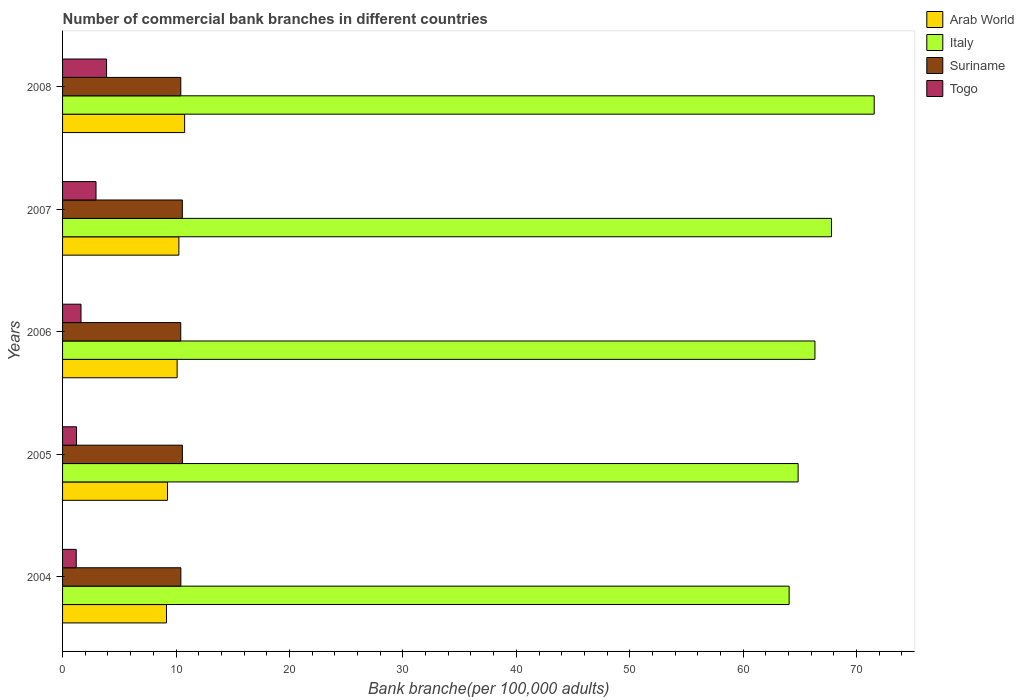How many different coloured bars are there?
Your answer should be very brief. 4. What is the number of commercial bank branches in Italy in 2005?
Give a very brief answer. 64.84. Across all years, what is the maximum number of commercial bank branches in Arab World?
Your answer should be compact. 10.76. Across all years, what is the minimum number of commercial bank branches in Suriname?
Provide a succinct answer. 10.42. In which year was the number of commercial bank branches in Arab World maximum?
Provide a short and direct response. 2008. What is the total number of commercial bank branches in Italy in the graph?
Your answer should be compact. 334.56. What is the difference between the number of commercial bank branches in Togo in 2004 and that in 2008?
Provide a short and direct response. -2.68. What is the difference between the number of commercial bank branches in Suriname in 2004 and the number of commercial bank branches in Arab World in 2006?
Your answer should be very brief. 0.33. What is the average number of commercial bank branches in Italy per year?
Keep it short and to the point. 66.91. In the year 2007, what is the difference between the number of commercial bank branches in Suriname and number of commercial bank branches in Arab World?
Your answer should be very brief. 0.31. In how many years, is the number of commercial bank branches in Togo greater than 36 ?
Your answer should be very brief. 0. What is the ratio of the number of commercial bank branches in Suriname in 2005 to that in 2008?
Give a very brief answer. 1.01. What is the difference between the highest and the second highest number of commercial bank branches in Suriname?
Give a very brief answer. 0. What is the difference between the highest and the lowest number of commercial bank branches in Togo?
Your response must be concise. 2.68. Is the sum of the number of commercial bank branches in Suriname in 2005 and 2007 greater than the maximum number of commercial bank branches in Arab World across all years?
Your answer should be compact. Yes. Is it the case that in every year, the sum of the number of commercial bank branches in Suriname and number of commercial bank branches in Arab World is greater than the number of commercial bank branches in Italy?
Offer a terse response. No. How many bars are there?
Offer a terse response. 20. Are all the bars in the graph horizontal?
Your response must be concise. Yes. How many years are there in the graph?
Provide a succinct answer. 5. Does the graph contain any zero values?
Provide a short and direct response. No. Does the graph contain grids?
Provide a short and direct response. No. What is the title of the graph?
Give a very brief answer. Number of commercial bank branches in different countries. What is the label or title of the X-axis?
Provide a short and direct response. Bank branche(per 100,0 adults). What is the label or title of the Y-axis?
Give a very brief answer. Years. What is the Bank branche(per 100,000 adults) in Arab World in 2004?
Your answer should be very brief. 9.16. What is the Bank branche(per 100,000 adults) of Italy in 2004?
Provide a succinct answer. 64.05. What is the Bank branche(per 100,000 adults) of Suriname in 2004?
Offer a very short reply. 10.43. What is the Bank branche(per 100,000 adults) of Togo in 2004?
Give a very brief answer. 1.2. What is the Bank branche(per 100,000 adults) of Arab World in 2005?
Provide a succinct answer. 9.25. What is the Bank branche(per 100,000 adults) in Italy in 2005?
Provide a succinct answer. 64.84. What is the Bank branche(per 100,000 adults) in Suriname in 2005?
Provide a succinct answer. 10.56. What is the Bank branche(per 100,000 adults) of Togo in 2005?
Your answer should be very brief. 1.23. What is the Bank branche(per 100,000 adults) of Arab World in 2006?
Make the answer very short. 10.1. What is the Bank branche(per 100,000 adults) in Italy in 2006?
Offer a very short reply. 66.33. What is the Bank branche(per 100,000 adults) of Suriname in 2006?
Offer a terse response. 10.42. What is the Bank branche(per 100,000 adults) of Togo in 2006?
Offer a very short reply. 1.63. What is the Bank branche(per 100,000 adults) in Arab World in 2007?
Provide a succinct answer. 10.25. What is the Bank branche(per 100,000 adults) in Italy in 2007?
Give a very brief answer. 67.78. What is the Bank branche(per 100,000 adults) of Suriname in 2007?
Provide a succinct answer. 10.56. What is the Bank branche(per 100,000 adults) in Togo in 2007?
Give a very brief answer. 2.95. What is the Bank branche(per 100,000 adults) in Arab World in 2008?
Provide a succinct answer. 10.76. What is the Bank branche(per 100,000 adults) in Italy in 2008?
Offer a terse response. 71.55. What is the Bank branche(per 100,000 adults) of Suriname in 2008?
Provide a succinct answer. 10.42. What is the Bank branche(per 100,000 adults) in Togo in 2008?
Your response must be concise. 3.88. Across all years, what is the maximum Bank branche(per 100,000 adults) in Arab World?
Make the answer very short. 10.76. Across all years, what is the maximum Bank branche(per 100,000 adults) of Italy?
Ensure brevity in your answer.  71.55. Across all years, what is the maximum Bank branche(per 100,000 adults) in Suriname?
Provide a succinct answer. 10.56. Across all years, what is the maximum Bank branche(per 100,000 adults) in Togo?
Provide a succinct answer. 3.88. Across all years, what is the minimum Bank branche(per 100,000 adults) of Arab World?
Your answer should be very brief. 9.16. Across all years, what is the minimum Bank branche(per 100,000 adults) in Italy?
Your response must be concise. 64.05. Across all years, what is the minimum Bank branche(per 100,000 adults) of Suriname?
Your response must be concise. 10.42. Across all years, what is the minimum Bank branche(per 100,000 adults) of Togo?
Your response must be concise. 1.2. What is the total Bank branche(per 100,000 adults) in Arab World in the graph?
Your response must be concise. 49.52. What is the total Bank branche(per 100,000 adults) of Italy in the graph?
Ensure brevity in your answer.  334.56. What is the total Bank branche(per 100,000 adults) in Suriname in the graph?
Ensure brevity in your answer.  52.39. What is the total Bank branche(per 100,000 adults) of Togo in the graph?
Your response must be concise. 10.89. What is the difference between the Bank branche(per 100,000 adults) in Arab World in 2004 and that in 2005?
Give a very brief answer. -0.09. What is the difference between the Bank branche(per 100,000 adults) of Italy in 2004 and that in 2005?
Your answer should be very brief. -0.79. What is the difference between the Bank branche(per 100,000 adults) in Suriname in 2004 and that in 2005?
Give a very brief answer. -0.14. What is the difference between the Bank branche(per 100,000 adults) in Togo in 2004 and that in 2005?
Keep it short and to the point. -0.03. What is the difference between the Bank branche(per 100,000 adults) in Arab World in 2004 and that in 2006?
Ensure brevity in your answer.  -0.94. What is the difference between the Bank branche(per 100,000 adults) in Italy in 2004 and that in 2006?
Provide a short and direct response. -2.28. What is the difference between the Bank branche(per 100,000 adults) in Suriname in 2004 and that in 2006?
Ensure brevity in your answer.  0.01. What is the difference between the Bank branche(per 100,000 adults) in Togo in 2004 and that in 2006?
Make the answer very short. -0.42. What is the difference between the Bank branche(per 100,000 adults) in Arab World in 2004 and that in 2007?
Your response must be concise. -1.09. What is the difference between the Bank branche(per 100,000 adults) in Italy in 2004 and that in 2007?
Ensure brevity in your answer.  -3.73. What is the difference between the Bank branche(per 100,000 adults) of Suriname in 2004 and that in 2007?
Ensure brevity in your answer.  -0.13. What is the difference between the Bank branche(per 100,000 adults) of Togo in 2004 and that in 2007?
Your answer should be very brief. -1.75. What is the difference between the Bank branche(per 100,000 adults) in Arab World in 2004 and that in 2008?
Make the answer very short. -1.6. What is the difference between the Bank branche(per 100,000 adults) in Italy in 2004 and that in 2008?
Offer a terse response. -7.5. What is the difference between the Bank branche(per 100,000 adults) of Suriname in 2004 and that in 2008?
Offer a very short reply. 0.01. What is the difference between the Bank branche(per 100,000 adults) of Togo in 2004 and that in 2008?
Keep it short and to the point. -2.68. What is the difference between the Bank branche(per 100,000 adults) in Arab World in 2005 and that in 2006?
Provide a short and direct response. -0.85. What is the difference between the Bank branche(per 100,000 adults) of Italy in 2005 and that in 2006?
Provide a succinct answer. -1.48. What is the difference between the Bank branche(per 100,000 adults) of Suriname in 2005 and that in 2006?
Provide a succinct answer. 0.14. What is the difference between the Bank branche(per 100,000 adults) of Togo in 2005 and that in 2006?
Offer a terse response. -0.39. What is the difference between the Bank branche(per 100,000 adults) of Arab World in 2005 and that in 2007?
Your answer should be very brief. -1. What is the difference between the Bank branche(per 100,000 adults) of Italy in 2005 and that in 2007?
Offer a terse response. -2.94. What is the difference between the Bank branche(per 100,000 adults) of Suriname in 2005 and that in 2007?
Keep it short and to the point. 0. What is the difference between the Bank branche(per 100,000 adults) of Togo in 2005 and that in 2007?
Ensure brevity in your answer.  -1.72. What is the difference between the Bank branche(per 100,000 adults) of Arab World in 2005 and that in 2008?
Provide a short and direct response. -1.51. What is the difference between the Bank branche(per 100,000 adults) of Italy in 2005 and that in 2008?
Provide a succinct answer. -6.71. What is the difference between the Bank branche(per 100,000 adults) in Suriname in 2005 and that in 2008?
Ensure brevity in your answer.  0.14. What is the difference between the Bank branche(per 100,000 adults) of Togo in 2005 and that in 2008?
Your response must be concise. -2.65. What is the difference between the Bank branche(per 100,000 adults) in Arab World in 2006 and that in 2007?
Your answer should be compact. -0.15. What is the difference between the Bank branche(per 100,000 adults) of Italy in 2006 and that in 2007?
Provide a succinct answer. -1.46. What is the difference between the Bank branche(per 100,000 adults) of Suriname in 2006 and that in 2007?
Your response must be concise. -0.14. What is the difference between the Bank branche(per 100,000 adults) in Togo in 2006 and that in 2007?
Your response must be concise. -1.32. What is the difference between the Bank branche(per 100,000 adults) of Arab World in 2006 and that in 2008?
Your answer should be very brief. -0.66. What is the difference between the Bank branche(per 100,000 adults) of Italy in 2006 and that in 2008?
Keep it short and to the point. -5.22. What is the difference between the Bank branche(per 100,000 adults) of Suriname in 2006 and that in 2008?
Make the answer very short. -0. What is the difference between the Bank branche(per 100,000 adults) in Togo in 2006 and that in 2008?
Make the answer very short. -2.25. What is the difference between the Bank branche(per 100,000 adults) in Arab World in 2007 and that in 2008?
Provide a succinct answer. -0.51. What is the difference between the Bank branche(per 100,000 adults) in Italy in 2007 and that in 2008?
Your answer should be very brief. -3.77. What is the difference between the Bank branche(per 100,000 adults) in Suriname in 2007 and that in 2008?
Offer a very short reply. 0.14. What is the difference between the Bank branche(per 100,000 adults) of Togo in 2007 and that in 2008?
Ensure brevity in your answer.  -0.93. What is the difference between the Bank branche(per 100,000 adults) of Arab World in 2004 and the Bank branche(per 100,000 adults) of Italy in 2005?
Offer a very short reply. -55.68. What is the difference between the Bank branche(per 100,000 adults) of Arab World in 2004 and the Bank branche(per 100,000 adults) of Suriname in 2005?
Ensure brevity in your answer.  -1.4. What is the difference between the Bank branche(per 100,000 adults) of Arab World in 2004 and the Bank branche(per 100,000 adults) of Togo in 2005?
Your answer should be very brief. 7.93. What is the difference between the Bank branche(per 100,000 adults) of Italy in 2004 and the Bank branche(per 100,000 adults) of Suriname in 2005?
Provide a short and direct response. 53.49. What is the difference between the Bank branche(per 100,000 adults) of Italy in 2004 and the Bank branche(per 100,000 adults) of Togo in 2005?
Make the answer very short. 62.82. What is the difference between the Bank branche(per 100,000 adults) of Suriname in 2004 and the Bank branche(per 100,000 adults) of Togo in 2005?
Your response must be concise. 9.2. What is the difference between the Bank branche(per 100,000 adults) in Arab World in 2004 and the Bank branche(per 100,000 adults) in Italy in 2006?
Ensure brevity in your answer.  -57.17. What is the difference between the Bank branche(per 100,000 adults) of Arab World in 2004 and the Bank branche(per 100,000 adults) of Suriname in 2006?
Offer a very short reply. -1.26. What is the difference between the Bank branche(per 100,000 adults) in Arab World in 2004 and the Bank branche(per 100,000 adults) in Togo in 2006?
Keep it short and to the point. 7.54. What is the difference between the Bank branche(per 100,000 adults) of Italy in 2004 and the Bank branche(per 100,000 adults) of Suriname in 2006?
Offer a terse response. 53.63. What is the difference between the Bank branche(per 100,000 adults) in Italy in 2004 and the Bank branche(per 100,000 adults) in Togo in 2006?
Keep it short and to the point. 62.43. What is the difference between the Bank branche(per 100,000 adults) in Suriname in 2004 and the Bank branche(per 100,000 adults) in Togo in 2006?
Your answer should be very brief. 8.8. What is the difference between the Bank branche(per 100,000 adults) of Arab World in 2004 and the Bank branche(per 100,000 adults) of Italy in 2007?
Provide a short and direct response. -58.62. What is the difference between the Bank branche(per 100,000 adults) in Arab World in 2004 and the Bank branche(per 100,000 adults) in Suriname in 2007?
Your answer should be compact. -1.4. What is the difference between the Bank branche(per 100,000 adults) of Arab World in 2004 and the Bank branche(per 100,000 adults) of Togo in 2007?
Ensure brevity in your answer.  6.21. What is the difference between the Bank branche(per 100,000 adults) of Italy in 2004 and the Bank branche(per 100,000 adults) of Suriname in 2007?
Offer a very short reply. 53.49. What is the difference between the Bank branche(per 100,000 adults) of Italy in 2004 and the Bank branche(per 100,000 adults) of Togo in 2007?
Ensure brevity in your answer.  61.1. What is the difference between the Bank branche(per 100,000 adults) of Suriname in 2004 and the Bank branche(per 100,000 adults) of Togo in 2007?
Provide a short and direct response. 7.48. What is the difference between the Bank branche(per 100,000 adults) of Arab World in 2004 and the Bank branche(per 100,000 adults) of Italy in 2008?
Offer a very short reply. -62.39. What is the difference between the Bank branche(per 100,000 adults) of Arab World in 2004 and the Bank branche(per 100,000 adults) of Suriname in 2008?
Keep it short and to the point. -1.26. What is the difference between the Bank branche(per 100,000 adults) of Arab World in 2004 and the Bank branche(per 100,000 adults) of Togo in 2008?
Provide a short and direct response. 5.28. What is the difference between the Bank branche(per 100,000 adults) in Italy in 2004 and the Bank branche(per 100,000 adults) in Suriname in 2008?
Keep it short and to the point. 53.63. What is the difference between the Bank branche(per 100,000 adults) in Italy in 2004 and the Bank branche(per 100,000 adults) in Togo in 2008?
Provide a short and direct response. 60.17. What is the difference between the Bank branche(per 100,000 adults) of Suriname in 2004 and the Bank branche(per 100,000 adults) of Togo in 2008?
Ensure brevity in your answer.  6.55. What is the difference between the Bank branche(per 100,000 adults) of Arab World in 2005 and the Bank branche(per 100,000 adults) of Italy in 2006?
Your response must be concise. -57.08. What is the difference between the Bank branche(per 100,000 adults) of Arab World in 2005 and the Bank branche(per 100,000 adults) of Suriname in 2006?
Your answer should be very brief. -1.17. What is the difference between the Bank branche(per 100,000 adults) in Arab World in 2005 and the Bank branche(per 100,000 adults) in Togo in 2006?
Offer a terse response. 7.62. What is the difference between the Bank branche(per 100,000 adults) in Italy in 2005 and the Bank branche(per 100,000 adults) in Suriname in 2006?
Make the answer very short. 54.43. What is the difference between the Bank branche(per 100,000 adults) in Italy in 2005 and the Bank branche(per 100,000 adults) in Togo in 2006?
Provide a succinct answer. 63.22. What is the difference between the Bank branche(per 100,000 adults) in Suriname in 2005 and the Bank branche(per 100,000 adults) in Togo in 2006?
Your response must be concise. 8.94. What is the difference between the Bank branche(per 100,000 adults) in Arab World in 2005 and the Bank branche(per 100,000 adults) in Italy in 2007?
Offer a very short reply. -58.53. What is the difference between the Bank branche(per 100,000 adults) in Arab World in 2005 and the Bank branche(per 100,000 adults) in Suriname in 2007?
Provide a short and direct response. -1.31. What is the difference between the Bank branche(per 100,000 adults) in Arab World in 2005 and the Bank branche(per 100,000 adults) in Togo in 2007?
Give a very brief answer. 6.3. What is the difference between the Bank branche(per 100,000 adults) in Italy in 2005 and the Bank branche(per 100,000 adults) in Suriname in 2007?
Provide a succinct answer. 54.29. What is the difference between the Bank branche(per 100,000 adults) in Italy in 2005 and the Bank branche(per 100,000 adults) in Togo in 2007?
Your response must be concise. 61.89. What is the difference between the Bank branche(per 100,000 adults) of Suriname in 2005 and the Bank branche(per 100,000 adults) of Togo in 2007?
Provide a short and direct response. 7.61. What is the difference between the Bank branche(per 100,000 adults) in Arab World in 2005 and the Bank branche(per 100,000 adults) in Italy in 2008?
Give a very brief answer. -62.3. What is the difference between the Bank branche(per 100,000 adults) of Arab World in 2005 and the Bank branche(per 100,000 adults) of Suriname in 2008?
Your answer should be compact. -1.17. What is the difference between the Bank branche(per 100,000 adults) of Arab World in 2005 and the Bank branche(per 100,000 adults) of Togo in 2008?
Your response must be concise. 5.37. What is the difference between the Bank branche(per 100,000 adults) of Italy in 2005 and the Bank branche(per 100,000 adults) of Suriname in 2008?
Offer a very short reply. 54.42. What is the difference between the Bank branche(per 100,000 adults) of Italy in 2005 and the Bank branche(per 100,000 adults) of Togo in 2008?
Your answer should be very brief. 60.96. What is the difference between the Bank branche(per 100,000 adults) in Suriname in 2005 and the Bank branche(per 100,000 adults) in Togo in 2008?
Offer a very short reply. 6.68. What is the difference between the Bank branche(per 100,000 adults) of Arab World in 2006 and the Bank branche(per 100,000 adults) of Italy in 2007?
Your answer should be very brief. -57.68. What is the difference between the Bank branche(per 100,000 adults) in Arab World in 2006 and the Bank branche(per 100,000 adults) in Suriname in 2007?
Make the answer very short. -0.46. What is the difference between the Bank branche(per 100,000 adults) in Arab World in 2006 and the Bank branche(per 100,000 adults) in Togo in 2007?
Your answer should be compact. 7.15. What is the difference between the Bank branche(per 100,000 adults) in Italy in 2006 and the Bank branche(per 100,000 adults) in Suriname in 2007?
Give a very brief answer. 55.77. What is the difference between the Bank branche(per 100,000 adults) in Italy in 2006 and the Bank branche(per 100,000 adults) in Togo in 2007?
Your answer should be very brief. 63.38. What is the difference between the Bank branche(per 100,000 adults) in Suriname in 2006 and the Bank branche(per 100,000 adults) in Togo in 2007?
Offer a very short reply. 7.47. What is the difference between the Bank branche(per 100,000 adults) in Arab World in 2006 and the Bank branche(per 100,000 adults) in Italy in 2008?
Ensure brevity in your answer.  -61.45. What is the difference between the Bank branche(per 100,000 adults) of Arab World in 2006 and the Bank branche(per 100,000 adults) of Suriname in 2008?
Offer a terse response. -0.32. What is the difference between the Bank branche(per 100,000 adults) in Arab World in 2006 and the Bank branche(per 100,000 adults) in Togo in 2008?
Make the answer very short. 6.22. What is the difference between the Bank branche(per 100,000 adults) of Italy in 2006 and the Bank branche(per 100,000 adults) of Suriname in 2008?
Make the answer very short. 55.9. What is the difference between the Bank branche(per 100,000 adults) in Italy in 2006 and the Bank branche(per 100,000 adults) in Togo in 2008?
Keep it short and to the point. 62.45. What is the difference between the Bank branche(per 100,000 adults) in Suriname in 2006 and the Bank branche(per 100,000 adults) in Togo in 2008?
Your response must be concise. 6.54. What is the difference between the Bank branche(per 100,000 adults) of Arab World in 2007 and the Bank branche(per 100,000 adults) of Italy in 2008?
Your answer should be very brief. -61.3. What is the difference between the Bank branche(per 100,000 adults) of Arab World in 2007 and the Bank branche(per 100,000 adults) of Suriname in 2008?
Ensure brevity in your answer.  -0.17. What is the difference between the Bank branche(per 100,000 adults) in Arab World in 2007 and the Bank branche(per 100,000 adults) in Togo in 2008?
Make the answer very short. 6.37. What is the difference between the Bank branche(per 100,000 adults) in Italy in 2007 and the Bank branche(per 100,000 adults) in Suriname in 2008?
Give a very brief answer. 57.36. What is the difference between the Bank branche(per 100,000 adults) of Italy in 2007 and the Bank branche(per 100,000 adults) of Togo in 2008?
Offer a terse response. 63.9. What is the difference between the Bank branche(per 100,000 adults) in Suriname in 2007 and the Bank branche(per 100,000 adults) in Togo in 2008?
Ensure brevity in your answer.  6.68. What is the average Bank branche(per 100,000 adults) of Arab World per year?
Ensure brevity in your answer.  9.9. What is the average Bank branche(per 100,000 adults) in Italy per year?
Provide a succinct answer. 66.91. What is the average Bank branche(per 100,000 adults) in Suriname per year?
Keep it short and to the point. 10.48. What is the average Bank branche(per 100,000 adults) of Togo per year?
Offer a terse response. 2.18. In the year 2004, what is the difference between the Bank branche(per 100,000 adults) of Arab World and Bank branche(per 100,000 adults) of Italy?
Keep it short and to the point. -54.89. In the year 2004, what is the difference between the Bank branche(per 100,000 adults) of Arab World and Bank branche(per 100,000 adults) of Suriname?
Ensure brevity in your answer.  -1.27. In the year 2004, what is the difference between the Bank branche(per 100,000 adults) of Arab World and Bank branche(per 100,000 adults) of Togo?
Offer a terse response. 7.96. In the year 2004, what is the difference between the Bank branche(per 100,000 adults) of Italy and Bank branche(per 100,000 adults) of Suriname?
Your answer should be compact. 53.62. In the year 2004, what is the difference between the Bank branche(per 100,000 adults) in Italy and Bank branche(per 100,000 adults) in Togo?
Your answer should be very brief. 62.85. In the year 2004, what is the difference between the Bank branche(per 100,000 adults) of Suriname and Bank branche(per 100,000 adults) of Togo?
Your response must be concise. 9.22. In the year 2005, what is the difference between the Bank branche(per 100,000 adults) in Arab World and Bank branche(per 100,000 adults) in Italy?
Your response must be concise. -55.59. In the year 2005, what is the difference between the Bank branche(per 100,000 adults) of Arab World and Bank branche(per 100,000 adults) of Suriname?
Your response must be concise. -1.31. In the year 2005, what is the difference between the Bank branche(per 100,000 adults) of Arab World and Bank branche(per 100,000 adults) of Togo?
Provide a short and direct response. 8.02. In the year 2005, what is the difference between the Bank branche(per 100,000 adults) in Italy and Bank branche(per 100,000 adults) in Suriname?
Your answer should be compact. 54.28. In the year 2005, what is the difference between the Bank branche(per 100,000 adults) in Italy and Bank branche(per 100,000 adults) in Togo?
Provide a succinct answer. 63.61. In the year 2005, what is the difference between the Bank branche(per 100,000 adults) in Suriname and Bank branche(per 100,000 adults) in Togo?
Make the answer very short. 9.33. In the year 2006, what is the difference between the Bank branche(per 100,000 adults) of Arab World and Bank branche(per 100,000 adults) of Italy?
Offer a terse response. -56.23. In the year 2006, what is the difference between the Bank branche(per 100,000 adults) in Arab World and Bank branche(per 100,000 adults) in Suriname?
Offer a terse response. -0.32. In the year 2006, what is the difference between the Bank branche(per 100,000 adults) in Arab World and Bank branche(per 100,000 adults) in Togo?
Give a very brief answer. 8.47. In the year 2006, what is the difference between the Bank branche(per 100,000 adults) in Italy and Bank branche(per 100,000 adults) in Suriname?
Your answer should be compact. 55.91. In the year 2006, what is the difference between the Bank branche(per 100,000 adults) in Italy and Bank branche(per 100,000 adults) in Togo?
Ensure brevity in your answer.  64.7. In the year 2006, what is the difference between the Bank branche(per 100,000 adults) in Suriname and Bank branche(per 100,000 adults) in Togo?
Offer a very short reply. 8.79. In the year 2007, what is the difference between the Bank branche(per 100,000 adults) in Arab World and Bank branche(per 100,000 adults) in Italy?
Your answer should be compact. -57.53. In the year 2007, what is the difference between the Bank branche(per 100,000 adults) of Arab World and Bank branche(per 100,000 adults) of Suriname?
Keep it short and to the point. -0.31. In the year 2007, what is the difference between the Bank branche(per 100,000 adults) in Arab World and Bank branche(per 100,000 adults) in Togo?
Give a very brief answer. 7.3. In the year 2007, what is the difference between the Bank branche(per 100,000 adults) of Italy and Bank branche(per 100,000 adults) of Suriname?
Keep it short and to the point. 57.22. In the year 2007, what is the difference between the Bank branche(per 100,000 adults) of Italy and Bank branche(per 100,000 adults) of Togo?
Your answer should be very brief. 64.83. In the year 2007, what is the difference between the Bank branche(per 100,000 adults) of Suriname and Bank branche(per 100,000 adults) of Togo?
Your answer should be very brief. 7.61. In the year 2008, what is the difference between the Bank branche(per 100,000 adults) of Arab World and Bank branche(per 100,000 adults) of Italy?
Keep it short and to the point. -60.79. In the year 2008, what is the difference between the Bank branche(per 100,000 adults) in Arab World and Bank branche(per 100,000 adults) in Suriname?
Offer a very short reply. 0.34. In the year 2008, what is the difference between the Bank branche(per 100,000 adults) in Arab World and Bank branche(per 100,000 adults) in Togo?
Your answer should be compact. 6.88. In the year 2008, what is the difference between the Bank branche(per 100,000 adults) in Italy and Bank branche(per 100,000 adults) in Suriname?
Your response must be concise. 61.13. In the year 2008, what is the difference between the Bank branche(per 100,000 adults) in Italy and Bank branche(per 100,000 adults) in Togo?
Your answer should be very brief. 67.67. In the year 2008, what is the difference between the Bank branche(per 100,000 adults) in Suriname and Bank branche(per 100,000 adults) in Togo?
Make the answer very short. 6.54. What is the ratio of the Bank branche(per 100,000 adults) in Arab World in 2004 to that in 2005?
Keep it short and to the point. 0.99. What is the ratio of the Bank branche(per 100,000 adults) of Italy in 2004 to that in 2005?
Make the answer very short. 0.99. What is the ratio of the Bank branche(per 100,000 adults) in Suriname in 2004 to that in 2005?
Keep it short and to the point. 0.99. What is the ratio of the Bank branche(per 100,000 adults) of Togo in 2004 to that in 2005?
Offer a very short reply. 0.98. What is the ratio of the Bank branche(per 100,000 adults) in Arab World in 2004 to that in 2006?
Your response must be concise. 0.91. What is the ratio of the Bank branche(per 100,000 adults) of Italy in 2004 to that in 2006?
Your answer should be very brief. 0.97. What is the ratio of the Bank branche(per 100,000 adults) in Suriname in 2004 to that in 2006?
Make the answer very short. 1. What is the ratio of the Bank branche(per 100,000 adults) in Togo in 2004 to that in 2006?
Ensure brevity in your answer.  0.74. What is the ratio of the Bank branche(per 100,000 adults) in Arab World in 2004 to that in 2007?
Ensure brevity in your answer.  0.89. What is the ratio of the Bank branche(per 100,000 adults) of Italy in 2004 to that in 2007?
Keep it short and to the point. 0.94. What is the ratio of the Bank branche(per 100,000 adults) in Suriname in 2004 to that in 2007?
Make the answer very short. 0.99. What is the ratio of the Bank branche(per 100,000 adults) in Togo in 2004 to that in 2007?
Make the answer very short. 0.41. What is the ratio of the Bank branche(per 100,000 adults) in Arab World in 2004 to that in 2008?
Give a very brief answer. 0.85. What is the ratio of the Bank branche(per 100,000 adults) in Italy in 2004 to that in 2008?
Your answer should be very brief. 0.9. What is the ratio of the Bank branche(per 100,000 adults) of Togo in 2004 to that in 2008?
Your answer should be compact. 0.31. What is the ratio of the Bank branche(per 100,000 adults) in Arab World in 2005 to that in 2006?
Offer a very short reply. 0.92. What is the ratio of the Bank branche(per 100,000 adults) in Italy in 2005 to that in 2006?
Your answer should be very brief. 0.98. What is the ratio of the Bank branche(per 100,000 adults) in Suriname in 2005 to that in 2006?
Make the answer very short. 1.01. What is the ratio of the Bank branche(per 100,000 adults) of Togo in 2005 to that in 2006?
Give a very brief answer. 0.76. What is the ratio of the Bank branche(per 100,000 adults) in Arab World in 2005 to that in 2007?
Ensure brevity in your answer.  0.9. What is the ratio of the Bank branche(per 100,000 adults) in Italy in 2005 to that in 2007?
Provide a short and direct response. 0.96. What is the ratio of the Bank branche(per 100,000 adults) of Togo in 2005 to that in 2007?
Offer a very short reply. 0.42. What is the ratio of the Bank branche(per 100,000 adults) in Arab World in 2005 to that in 2008?
Keep it short and to the point. 0.86. What is the ratio of the Bank branche(per 100,000 adults) in Italy in 2005 to that in 2008?
Your response must be concise. 0.91. What is the ratio of the Bank branche(per 100,000 adults) of Suriname in 2005 to that in 2008?
Give a very brief answer. 1.01. What is the ratio of the Bank branche(per 100,000 adults) of Togo in 2005 to that in 2008?
Make the answer very short. 0.32. What is the ratio of the Bank branche(per 100,000 adults) in Italy in 2006 to that in 2007?
Make the answer very short. 0.98. What is the ratio of the Bank branche(per 100,000 adults) in Suriname in 2006 to that in 2007?
Make the answer very short. 0.99. What is the ratio of the Bank branche(per 100,000 adults) of Togo in 2006 to that in 2007?
Your response must be concise. 0.55. What is the ratio of the Bank branche(per 100,000 adults) in Arab World in 2006 to that in 2008?
Keep it short and to the point. 0.94. What is the ratio of the Bank branche(per 100,000 adults) in Italy in 2006 to that in 2008?
Your answer should be compact. 0.93. What is the ratio of the Bank branche(per 100,000 adults) of Suriname in 2006 to that in 2008?
Provide a succinct answer. 1. What is the ratio of the Bank branche(per 100,000 adults) of Togo in 2006 to that in 2008?
Make the answer very short. 0.42. What is the ratio of the Bank branche(per 100,000 adults) in Arab World in 2007 to that in 2008?
Provide a short and direct response. 0.95. What is the ratio of the Bank branche(per 100,000 adults) in Italy in 2007 to that in 2008?
Provide a succinct answer. 0.95. What is the ratio of the Bank branche(per 100,000 adults) in Suriname in 2007 to that in 2008?
Your response must be concise. 1.01. What is the ratio of the Bank branche(per 100,000 adults) of Togo in 2007 to that in 2008?
Provide a succinct answer. 0.76. What is the difference between the highest and the second highest Bank branche(per 100,000 adults) in Arab World?
Your answer should be very brief. 0.51. What is the difference between the highest and the second highest Bank branche(per 100,000 adults) in Italy?
Provide a short and direct response. 3.77. What is the difference between the highest and the second highest Bank branche(per 100,000 adults) of Suriname?
Provide a short and direct response. 0. What is the difference between the highest and the second highest Bank branche(per 100,000 adults) of Togo?
Offer a very short reply. 0.93. What is the difference between the highest and the lowest Bank branche(per 100,000 adults) in Arab World?
Make the answer very short. 1.6. What is the difference between the highest and the lowest Bank branche(per 100,000 adults) in Italy?
Your answer should be very brief. 7.5. What is the difference between the highest and the lowest Bank branche(per 100,000 adults) of Suriname?
Ensure brevity in your answer.  0.14. What is the difference between the highest and the lowest Bank branche(per 100,000 adults) in Togo?
Make the answer very short. 2.68. 